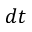<formula> <loc_0><loc_0><loc_500><loc_500>d t</formula> 